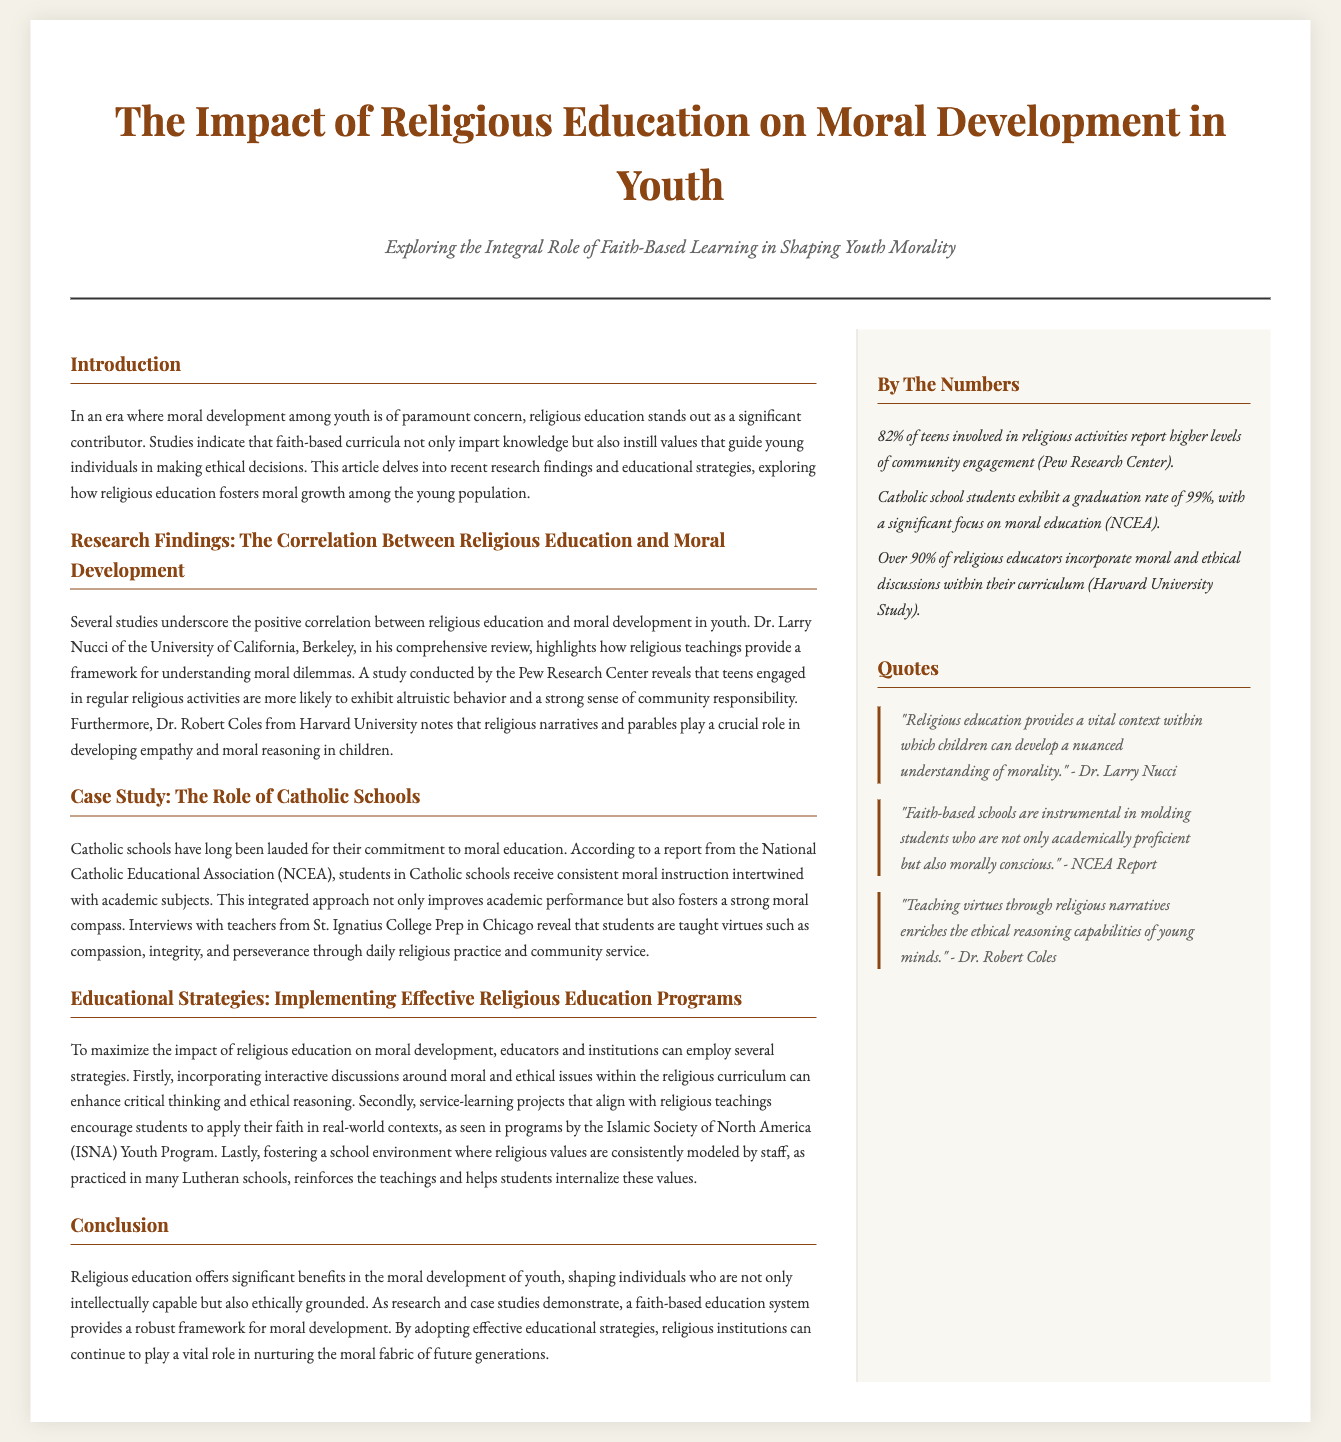What is the main focus of the article? The article focuses on the impact of religious education on the moral development of youth.
Answer: Impact of religious education on moral development of youth Who conducted a comprehensive review highlighting religious teachings' role in moral dilemmas? Dr. Larry Nucci from the University of California, Berkeley conducted the comprehensive review.
Answer: Dr. Larry Nucci What percentage of teens involved in religious activities report higher community engagement? According to the Pew Research Center, 82% of teens report higher levels of community engagement.
Answer: 82% Which educational strategy is mentioned as beneficial for moral development? Incorporating interactive discussions around moral and ethical issues within the religious curriculum is mentioned as beneficial.
Answer: Interactive discussions What is the graduation rate of Catholic school students? The graduation rate of Catholic school students is 99%.
Answer: 99% Which organization is associated with the Youth Program that encourages service-learning projects? The Islamic Society of North America (ISNA) is associated with the Youth Program.
Answer: Islamic Society of North America (ISNA) What is the color scheme used in the newspaper layout? The layout features a background color of #f4f1e8 and text color of #333.
Answer: #f4f1e8 and #333 What format do the quotes in the sidebar section follow? The quotes in the sidebar section are attributed to specific individuals and highlighted in blockquotes.
Answer: Blockquotes 